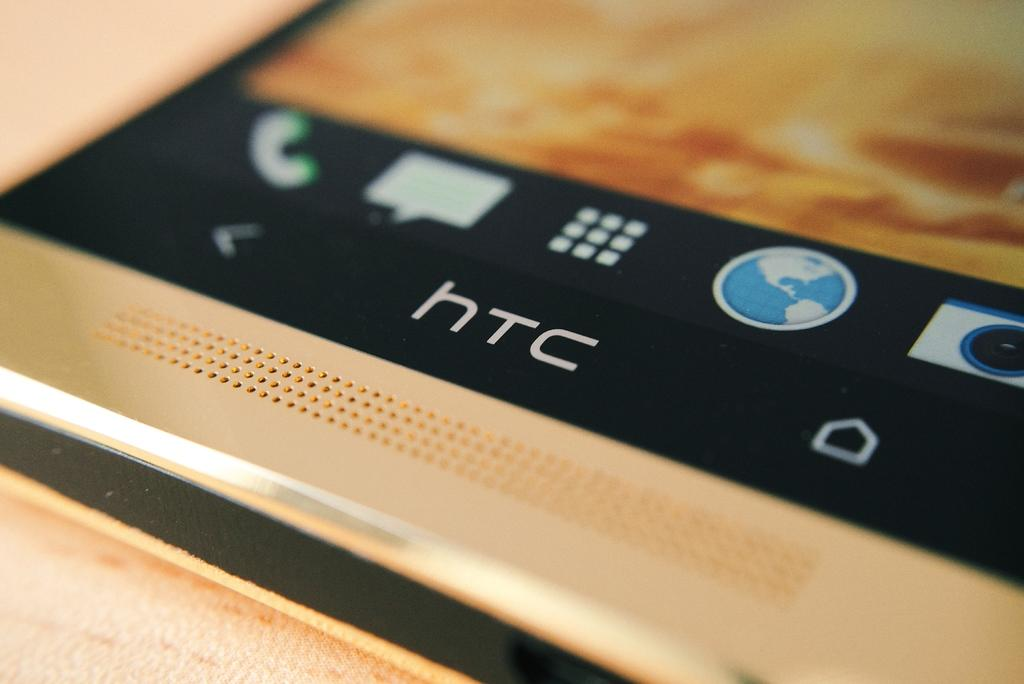<image>
Summarize the visual content of the image. A HTC smart phone with the screen unlocked. 